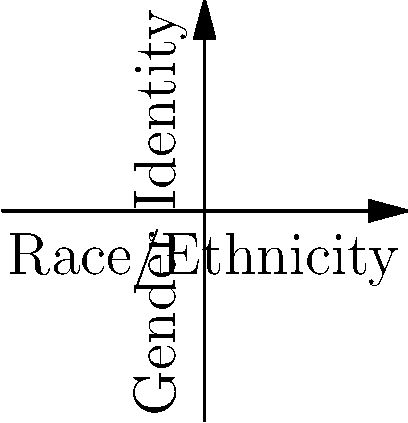In the intersectional identity coordinate system shown above, three individuals (A, B, and C) are mapped based on their race/ethnicity (x-axis), gender identity (y-axis), and socioeconomic status (z-axis). Each axis ranges from 0 (least privileged) to 1 (most privileged). Which individual likely experiences the most systemic barriers according to intersectionality theory, and why? To determine which individual likely experiences the most systemic barriers, we need to analyze their positions on each axis and consider the concept of intersectionality. Let's break it down step-by-step:

1. Examine each individual's position:
   A: (0.5, 0.3, 0.7)
   B: (0.2, 0.8, 0.4)
   C: (0.7, 0.6, 0.2)

2. Interpret the axes:
   - X-axis (Race/Ethnicity): Lower values indicate marginalized racial/ethnic groups
   - Y-axis (Gender Identity): Lower values indicate marginalized gender identities
   - Z-axis (Socioeconomic Status): Lower values indicate lower socioeconomic status

3. Analyze each individual:
   A: Moderate race/ethnicity privilege, low gender privilege, high socioeconomic privilege
   B: Low race/ethnicity privilege, high gender privilege, moderate socioeconomic privilege
   C: High race/ethnicity privilege, moderate gender privilege, low socioeconomic privilege

4. Apply intersectionality theory:
   Intersectionality suggests that individuals with multiple marginalized identities face compounded systemic barriers.

5. Compare the individuals:
   - A has one low value (gender)
   - B has one low value (race/ethnicity)
   - C has one low value (socioeconomic status)

6. Consider the overall position:
   C has the lowest combined value (0.7 + 0.6 + 0.2 = 1.5) compared to A (1.5) and B (1.4)

Based on this analysis, individual C likely experiences the most systemic barriers. Despite having racial/ethnic and gender privilege, their low socioeconomic status intersects with moderate gender privilege, potentially creating unique challenges that may be overlooked in single-axis analyses of discrimination.
Answer: Individual C, due to the intersection of low socioeconomic status with moderate gender privilege. 